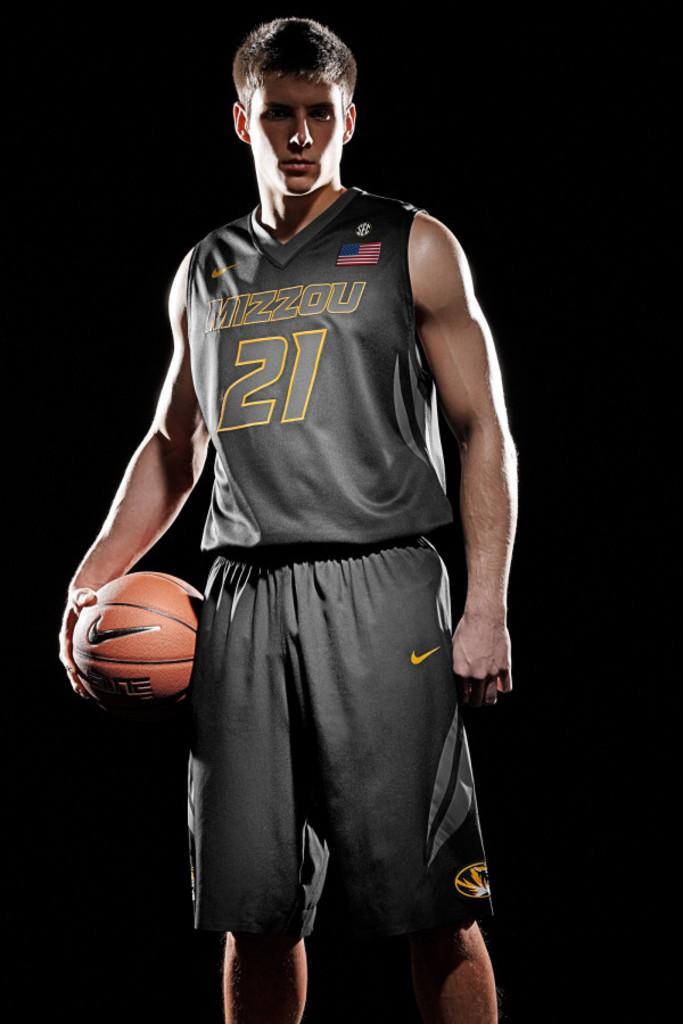Provide a one-sentence caption for the provided image. Basketball player in grey uniform printed MIZZOU 21 on jersey. 